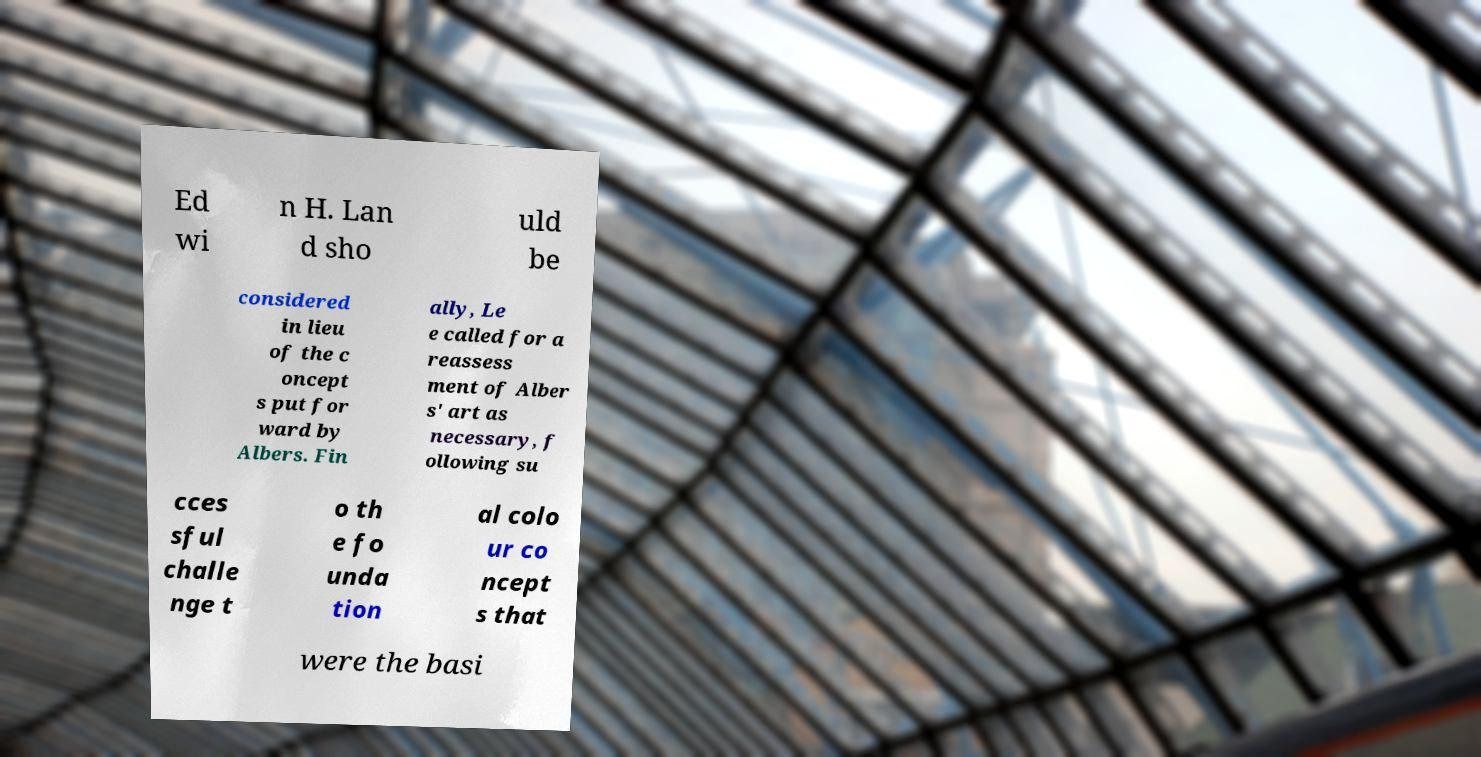Could you extract and type out the text from this image? Ed wi n H. Lan d sho uld be considered in lieu of the c oncept s put for ward by Albers. Fin ally, Le e called for a reassess ment of Alber s' art as necessary, f ollowing su cces sful challe nge t o th e fo unda tion al colo ur co ncept s that were the basi 